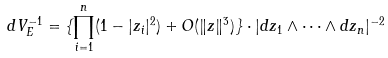<formula> <loc_0><loc_0><loc_500><loc_500>d V _ { E } ^ { - 1 } = \{ \prod _ { i = 1 } ^ { n } ( 1 - | z _ { i } | ^ { 2 } ) + O ( \| z \| ^ { 3 } ) \} \cdot | d z _ { 1 } \wedge \cdots \wedge d z _ { n } | ^ { - 2 }</formula> 